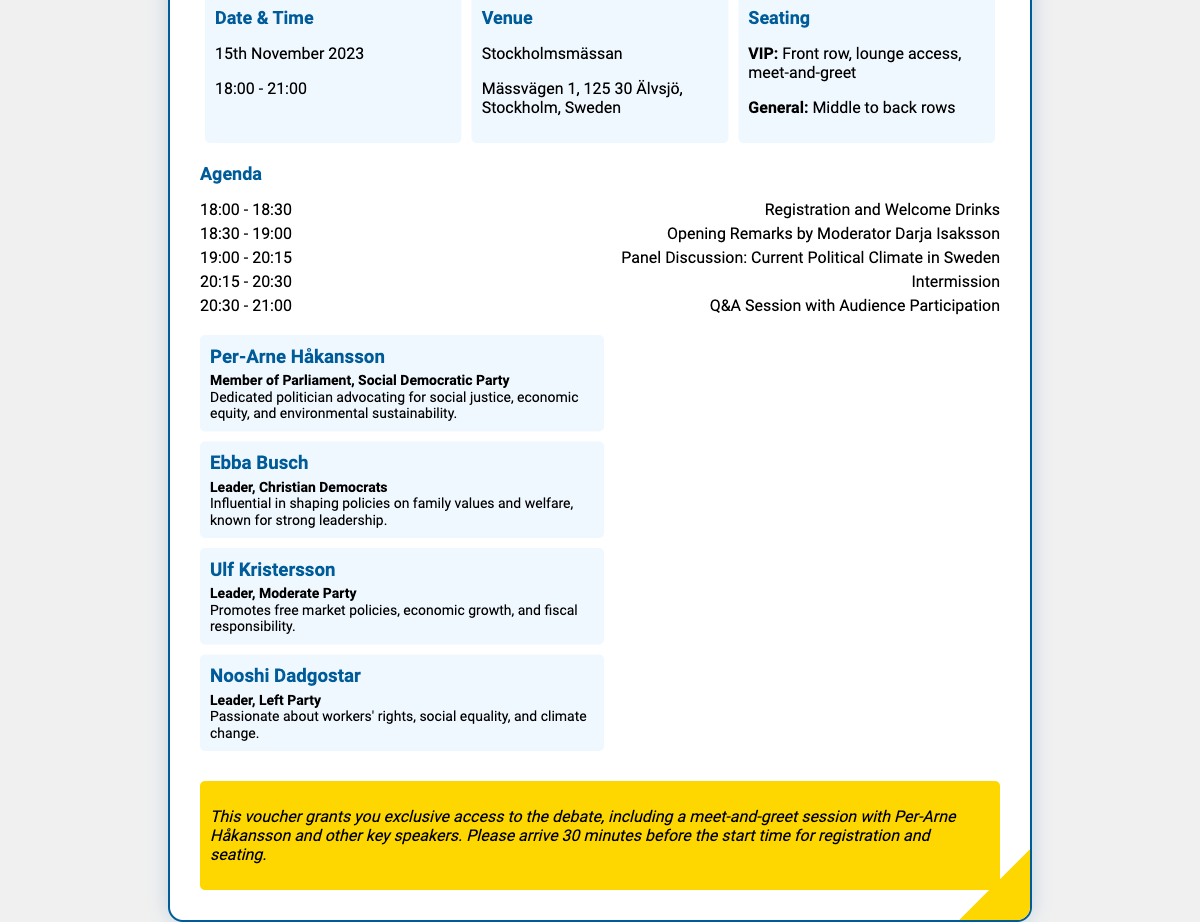What is the date of the event? The event is scheduled for November 15, 2023, which is explicitly stated in the document.
Answer: November 15, 2023 What is the venue of the political debate? The document provides the venue as Stockholmsmässan, including the address.
Answer: Stockholmsmässan Who is the moderator for the event? The document mentions that Darja Isaksson will serve as the moderator during the opening remarks.
Answer: Darja Isaksson What time does the debate start? The start time for the debate is listed as 18:00, as indicated in the agenda section.
Answer: 18:00 How long is the panel discussion scheduled to last? The agenda details specify that the panel discussion will occur from 19:00 to 20:15, equating to 1 hour and 15 minutes.
Answer: 1 hour and 15 minutes Which seating option includes a meet-and-greet? The document indicates that the VIP seating includes a meet-and-greet session with the speakers, specifically mentioned in the seating details.
Answer: VIP Name one main speaker besides Per-Arne Håkansson. The speakers section lists multiple individuals, one of whom can be identified as Ebba Busch.
Answer: Ebba Busch What type of political party does Per-Arne Håkansson represent? The document states that Per-Arne Håkansson is a member of the Social Democratic Party, providing specific party affiliation.
Answer: Social Democratic Party What unique opportunity does this voucher provide? The document highlights that the voucher grants exclusive access to a meet-and-greet session with the main speakers, including Per-Arne Håkansson.
Answer: Meet-and-greet session 